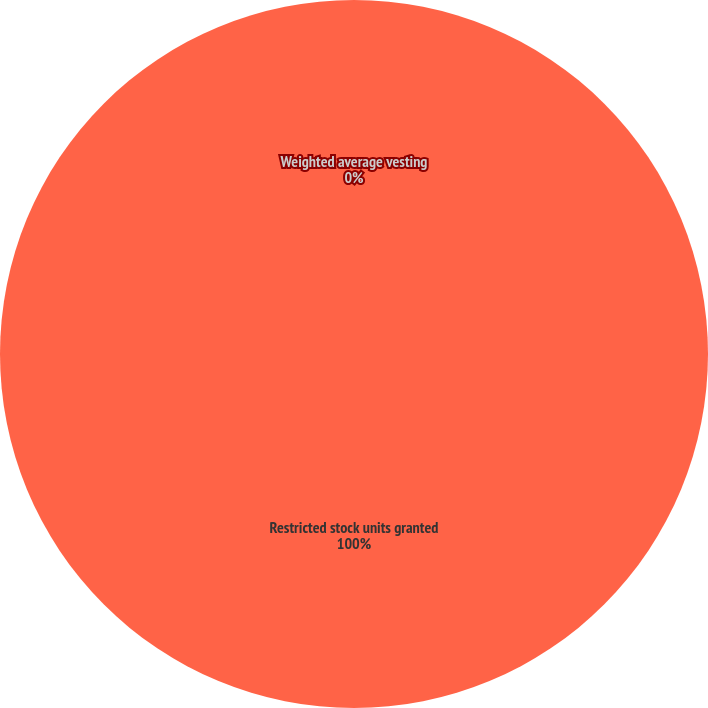Convert chart. <chart><loc_0><loc_0><loc_500><loc_500><pie_chart><fcel>Restricted stock units granted<fcel>Weighted average vesting<nl><fcel>100.0%<fcel>0.0%<nl></chart> 